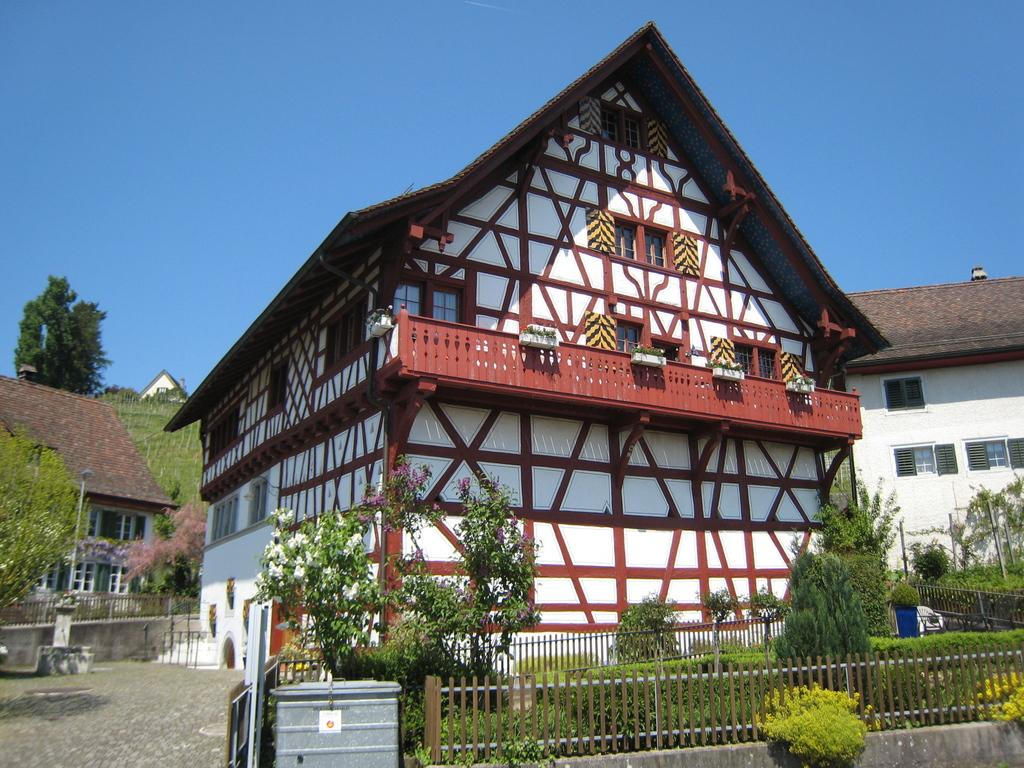What is the main feature in the center of the image? There is sky in the center of the image. What type of structures can be seen in the image? There are buildings in the image. What part of the buildings can be seen in the image? Windows are visible in the image. What type of natural elements are present in the image? Trees and plants are in the image. What type of man-made structures can be seen in the image? Fences are in the image. Are there any other objects visible in the image? Yes, there are a few other objects in the image. What type of record can be seen spinning on a turntable in the image? There is no record or turntable present in the image. What color is the stocking hanging from the window in the image? There is no stocking hanging from a window in the image. 